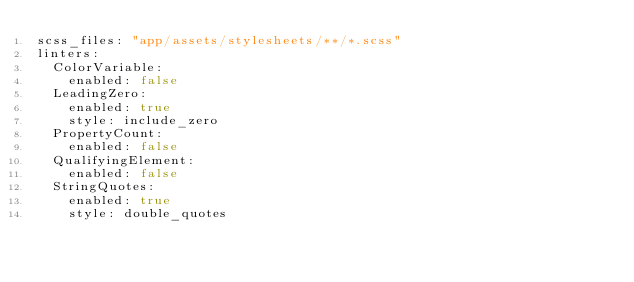Convert code to text. <code><loc_0><loc_0><loc_500><loc_500><_YAML_>scss_files: "app/assets/stylesheets/**/*.scss"
linters:
  ColorVariable:
    enabled: false
  LeadingZero:
    enabled: true
    style: include_zero
  PropertyCount:
    enabled: false
  QualifyingElement:
    enabled: false
  StringQuotes:
    enabled: true
    style: double_quotes
</code> 